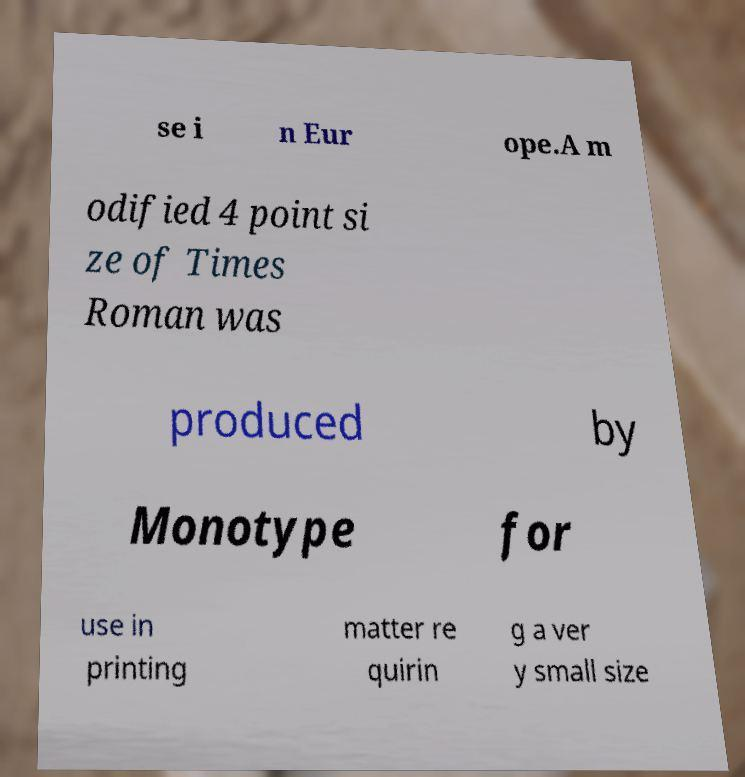Can you accurately transcribe the text from the provided image for me? se i n Eur ope.A m odified 4 point si ze of Times Roman was produced by Monotype for use in printing matter re quirin g a ver y small size 